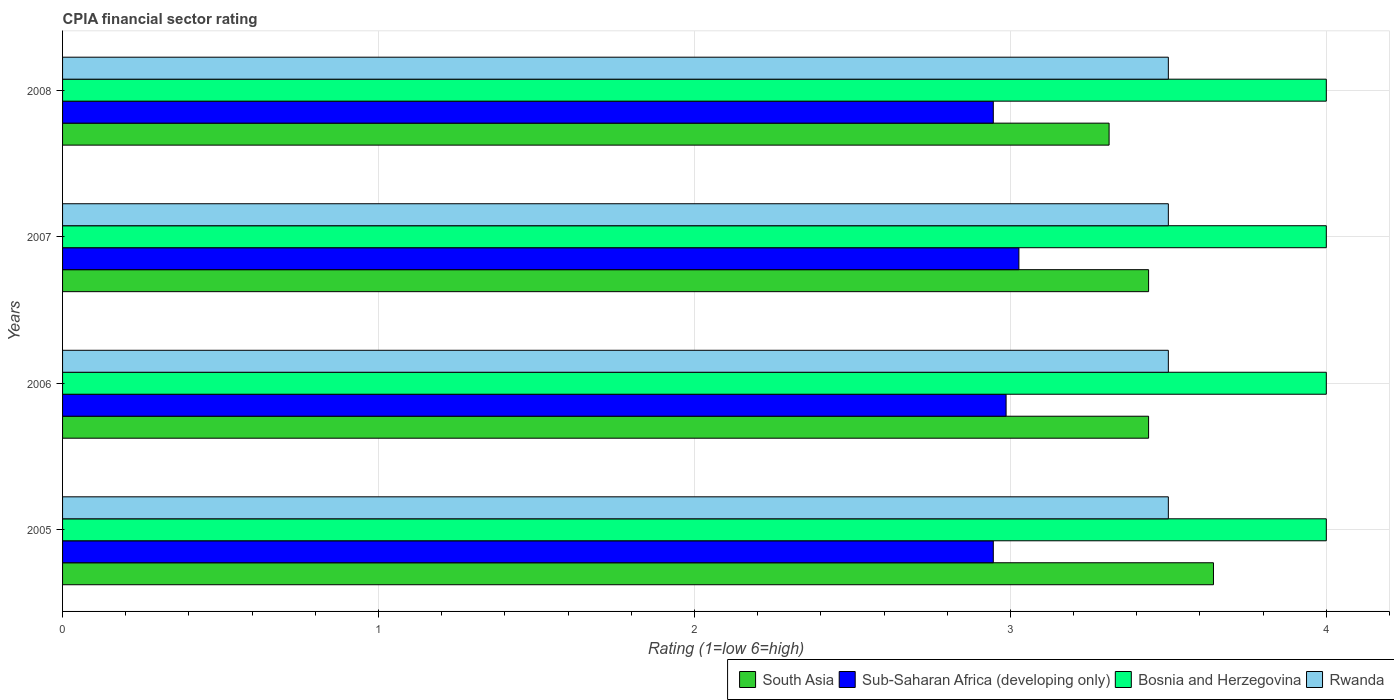How many different coloured bars are there?
Provide a short and direct response. 4. Are the number of bars on each tick of the Y-axis equal?
Give a very brief answer. Yes. How many bars are there on the 2nd tick from the top?
Provide a succinct answer. 4. What is the label of the 2nd group of bars from the top?
Your answer should be very brief. 2007. In how many cases, is the number of bars for a given year not equal to the number of legend labels?
Make the answer very short. 0. What is the CPIA rating in Sub-Saharan Africa (developing only) in 2007?
Make the answer very short. 3.03. Across all years, what is the maximum CPIA rating in South Asia?
Keep it short and to the point. 3.64. In which year was the CPIA rating in Rwanda maximum?
Offer a terse response. 2005. What is the difference between the CPIA rating in South Asia in 2005 and that in 2007?
Your answer should be very brief. 0.21. What is the difference between the CPIA rating in South Asia in 2006 and the CPIA rating in Sub-Saharan Africa (developing only) in 2007?
Offer a very short reply. 0.41. What is the average CPIA rating in Sub-Saharan Africa (developing only) per year?
Give a very brief answer. 2.98. In the year 2006, what is the difference between the CPIA rating in Sub-Saharan Africa (developing only) and CPIA rating in Bosnia and Herzegovina?
Give a very brief answer. -1.01. In how many years, is the CPIA rating in Rwanda greater than 1.6 ?
Offer a very short reply. 4. Is it the case that in every year, the sum of the CPIA rating in Sub-Saharan Africa (developing only) and CPIA rating in Rwanda is greater than the sum of CPIA rating in South Asia and CPIA rating in Bosnia and Herzegovina?
Offer a very short reply. No. What does the 1st bar from the top in 2007 represents?
Give a very brief answer. Rwanda. Is it the case that in every year, the sum of the CPIA rating in Rwanda and CPIA rating in Bosnia and Herzegovina is greater than the CPIA rating in Sub-Saharan Africa (developing only)?
Your response must be concise. Yes. What is the difference between two consecutive major ticks on the X-axis?
Your answer should be compact. 1. Does the graph contain any zero values?
Your response must be concise. No. How are the legend labels stacked?
Provide a succinct answer. Horizontal. What is the title of the graph?
Your response must be concise. CPIA financial sector rating. What is the label or title of the X-axis?
Your response must be concise. Rating (1=low 6=high). What is the label or title of the Y-axis?
Offer a terse response. Years. What is the Rating (1=low 6=high) of South Asia in 2005?
Offer a very short reply. 3.64. What is the Rating (1=low 6=high) of Sub-Saharan Africa (developing only) in 2005?
Provide a short and direct response. 2.95. What is the Rating (1=low 6=high) of Rwanda in 2005?
Offer a terse response. 3.5. What is the Rating (1=low 6=high) of South Asia in 2006?
Your answer should be very brief. 3.44. What is the Rating (1=low 6=high) of Sub-Saharan Africa (developing only) in 2006?
Your answer should be compact. 2.99. What is the Rating (1=low 6=high) in South Asia in 2007?
Your response must be concise. 3.44. What is the Rating (1=low 6=high) in Sub-Saharan Africa (developing only) in 2007?
Make the answer very short. 3.03. What is the Rating (1=low 6=high) in Rwanda in 2007?
Your response must be concise. 3.5. What is the Rating (1=low 6=high) in South Asia in 2008?
Provide a succinct answer. 3.31. What is the Rating (1=low 6=high) of Sub-Saharan Africa (developing only) in 2008?
Offer a very short reply. 2.95. Across all years, what is the maximum Rating (1=low 6=high) of South Asia?
Provide a succinct answer. 3.64. Across all years, what is the maximum Rating (1=low 6=high) in Sub-Saharan Africa (developing only)?
Your response must be concise. 3.03. Across all years, what is the maximum Rating (1=low 6=high) of Bosnia and Herzegovina?
Ensure brevity in your answer.  4. Across all years, what is the maximum Rating (1=low 6=high) of Rwanda?
Make the answer very short. 3.5. Across all years, what is the minimum Rating (1=low 6=high) in South Asia?
Your answer should be compact. 3.31. Across all years, what is the minimum Rating (1=low 6=high) in Sub-Saharan Africa (developing only)?
Give a very brief answer. 2.95. Across all years, what is the minimum Rating (1=low 6=high) of Bosnia and Herzegovina?
Ensure brevity in your answer.  4. Across all years, what is the minimum Rating (1=low 6=high) in Rwanda?
Your answer should be compact. 3.5. What is the total Rating (1=low 6=high) in South Asia in the graph?
Ensure brevity in your answer.  13.83. What is the total Rating (1=low 6=high) of Sub-Saharan Africa (developing only) in the graph?
Give a very brief answer. 11.91. What is the total Rating (1=low 6=high) in Bosnia and Herzegovina in the graph?
Your answer should be very brief. 16. What is the total Rating (1=low 6=high) of Rwanda in the graph?
Make the answer very short. 14. What is the difference between the Rating (1=low 6=high) of South Asia in 2005 and that in 2006?
Provide a succinct answer. 0.21. What is the difference between the Rating (1=low 6=high) in Sub-Saharan Africa (developing only) in 2005 and that in 2006?
Ensure brevity in your answer.  -0.04. What is the difference between the Rating (1=low 6=high) of South Asia in 2005 and that in 2007?
Provide a succinct answer. 0.21. What is the difference between the Rating (1=low 6=high) of Sub-Saharan Africa (developing only) in 2005 and that in 2007?
Make the answer very short. -0.08. What is the difference between the Rating (1=low 6=high) in Bosnia and Herzegovina in 2005 and that in 2007?
Provide a short and direct response. 0. What is the difference between the Rating (1=low 6=high) in South Asia in 2005 and that in 2008?
Ensure brevity in your answer.  0.33. What is the difference between the Rating (1=low 6=high) in Sub-Saharan Africa (developing only) in 2005 and that in 2008?
Your answer should be very brief. 0. What is the difference between the Rating (1=low 6=high) in Sub-Saharan Africa (developing only) in 2006 and that in 2007?
Your response must be concise. -0.04. What is the difference between the Rating (1=low 6=high) in Bosnia and Herzegovina in 2006 and that in 2007?
Keep it short and to the point. 0. What is the difference between the Rating (1=low 6=high) of Rwanda in 2006 and that in 2007?
Ensure brevity in your answer.  0. What is the difference between the Rating (1=low 6=high) in Sub-Saharan Africa (developing only) in 2006 and that in 2008?
Give a very brief answer. 0.04. What is the difference between the Rating (1=low 6=high) of Rwanda in 2006 and that in 2008?
Your response must be concise. 0. What is the difference between the Rating (1=low 6=high) in South Asia in 2007 and that in 2008?
Provide a succinct answer. 0.12. What is the difference between the Rating (1=low 6=high) of Sub-Saharan Africa (developing only) in 2007 and that in 2008?
Provide a succinct answer. 0.08. What is the difference between the Rating (1=low 6=high) in Rwanda in 2007 and that in 2008?
Your response must be concise. 0. What is the difference between the Rating (1=low 6=high) of South Asia in 2005 and the Rating (1=low 6=high) of Sub-Saharan Africa (developing only) in 2006?
Your answer should be very brief. 0.66. What is the difference between the Rating (1=low 6=high) in South Asia in 2005 and the Rating (1=low 6=high) in Bosnia and Herzegovina in 2006?
Your answer should be compact. -0.36. What is the difference between the Rating (1=low 6=high) of South Asia in 2005 and the Rating (1=low 6=high) of Rwanda in 2006?
Ensure brevity in your answer.  0.14. What is the difference between the Rating (1=low 6=high) in Sub-Saharan Africa (developing only) in 2005 and the Rating (1=low 6=high) in Bosnia and Herzegovina in 2006?
Your answer should be very brief. -1.05. What is the difference between the Rating (1=low 6=high) of Sub-Saharan Africa (developing only) in 2005 and the Rating (1=low 6=high) of Rwanda in 2006?
Provide a succinct answer. -0.55. What is the difference between the Rating (1=low 6=high) in Bosnia and Herzegovina in 2005 and the Rating (1=low 6=high) in Rwanda in 2006?
Your answer should be compact. 0.5. What is the difference between the Rating (1=low 6=high) in South Asia in 2005 and the Rating (1=low 6=high) in Sub-Saharan Africa (developing only) in 2007?
Give a very brief answer. 0.62. What is the difference between the Rating (1=low 6=high) in South Asia in 2005 and the Rating (1=low 6=high) in Bosnia and Herzegovina in 2007?
Provide a succinct answer. -0.36. What is the difference between the Rating (1=low 6=high) in South Asia in 2005 and the Rating (1=low 6=high) in Rwanda in 2007?
Offer a terse response. 0.14. What is the difference between the Rating (1=low 6=high) of Sub-Saharan Africa (developing only) in 2005 and the Rating (1=low 6=high) of Bosnia and Herzegovina in 2007?
Your answer should be compact. -1.05. What is the difference between the Rating (1=low 6=high) in Sub-Saharan Africa (developing only) in 2005 and the Rating (1=low 6=high) in Rwanda in 2007?
Offer a very short reply. -0.55. What is the difference between the Rating (1=low 6=high) of Bosnia and Herzegovina in 2005 and the Rating (1=low 6=high) of Rwanda in 2007?
Your answer should be compact. 0.5. What is the difference between the Rating (1=low 6=high) of South Asia in 2005 and the Rating (1=low 6=high) of Sub-Saharan Africa (developing only) in 2008?
Offer a terse response. 0.7. What is the difference between the Rating (1=low 6=high) of South Asia in 2005 and the Rating (1=low 6=high) of Bosnia and Herzegovina in 2008?
Offer a very short reply. -0.36. What is the difference between the Rating (1=low 6=high) in South Asia in 2005 and the Rating (1=low 6=high) in Rwanda in 2008?
Make the answer very short. 0.14. What is the difference between the Rating (1=low 6=high) of Sub-Saharan Africa (developing only) in 2005 and the Rating (1=low 6=high) of Bosnia and Herzegovina in 2008?
Keep it short and to the point. -1.05. What is the difference between the Rating (1=low 6=high) in Sub-Saharan Africa (developing only) in 2005 and the Rating (1=low 6=high) in Rwanda in 2008?
Your answer should be compact. -0.55. What is the difference between the Rating (1=low 6=high) of Bosnia and Herzegovina in 2005 and the Rating (1=low 6=high) of Rwanda in 2008?
Ensure brevity in your answer.  0.5. What is the difference between the Rating (1=low 6=high) of South Asia in 2006 and the Rating (1=low 6=high) of Sub-Saharan Africa (developing only) in 2007?
Keep it short and to the point. 0.41. What is the difference between the Rating (1=low 6=high) in South Asia in 2006 and the Rating (1=low 6=high) in Bosnia and Herzegovina in 2007?
Offer a very short reply. -0.56. What is the difference between the Rating (1=low 6=high) in South Asia in 2006 and the Rating (1=low 6=high) in Rwanda in 2007?
Ensure brevity in your answer.  -0.06. What is the difference between the Rating (1=low 6=high) in Sub-Saharan Africa (developing only) in 2006 and the Rating (1=low 6=high) in Bosnia and Herzegovina in 2007?
Provide a short and direct response. -1.01. What is the difference between the Rating (1=low 6=high) in Sub-Saharan Africa (developing only) in 2006 and the Rating (1=low 6=high) in Rwanda in 2007?
Your answer should be very brief. -0.51. What is the difference between the Rating (1=low 6=high) of Bosnia and Herzegovina in 2006 and the Rating (1=low 6=high) of Rwanda in 2007?
Your response must be concise. 0.5. What is the difference between the Rating (1=low 6=high) in South Asia in 2006 and the Rating (1=low 6=high) in Sub-Saharan Africa (developing only) in 2008?
Give a very brief answer. 0.49. What is the difference between the Rating (1=low 6=high) of South Asia in 2006 and the Rating (1=low 6=high) of Bosnia and Herzegovina in 2008?
Offer a very short reply. -0.56. What is the difference between the Rating (1=low 6=high) of South Asia in 2006 and the Rating (1=low 6=high) of Rwanda in 2008?
Provide a succinct answer. -0.06. What is the difference between the Rating (1=low 6=high) of Sub-Saharan Africa (developing only) in 2006 and the Rating (1=low 6=high) of Bosnia and Herzegovina in 2008?
Give a very brief answer. -1.01. What is the difference between the Rating (1=low 6=high) of Sub-Saharan Africa (developing only) in 2006 and the Rating (1=low 6=high) of Rwanda in 2008?
Make the answer very short. -0.51. What is the difference between the Rating (1=low 6=high) in South Asia in 2007 and the Rating (1=low 6=high) in Sub-Saharan Africa (developing only) in 2008?
Ensure brevity in your answer.  0.49. What is the difference between the Rating (1=low 6=high) in South Asia in 2007 and the Rating (1=low 6=high) in Bosnia and Herzegovina in 2008?
Provide a short and direct response. -0.56. What is the difference between the Rating (1=low 6=high) in South Asia in 2007 and the Rating (1=low 6=high) in Rwanda in 2008?
Make the answer very short. -0.06. What is the difference between the Rating (1=low 6=high) of Sub-Saharan Africa (developing only) in 2007 and the Rating (1=low 6=high) of Bosnia and Herzegovina in 2008?
Provide a succinct answer. -0.97. What is the difference between the Rating (1=low 6=high) of Sub-Saharan Africa (developing only) in 2007 and the Rating (1=low 6=high) of Rwanda in 2008?
Provide a succinct answer. -0.47. What is the difference between the Rating (1=low 6=high) in Bosnia and Herzegovina in 2007 and the Rating (1=low 6=high) in Rwanda in 2008?
Make the answer very short. 0.5. What is the average Rating (1=low 6=high) in South Asia per year?
Your response must be concise. 3.46. What is the average Rating (1=low 6=high) in Sub-Saharan Africa (developing only) per year?
Your answer should be compact. 2.98. In the year 2005, what is the difference between the Rating (1=low 6=high) of South Asia and Rating (1=low 6=high) of Sub-Saharan Africa (developing only)?
Give a very brief answer. 0.7. In the year 2005, what is the difference between the Rating (1=low 6=high) in South Asia and Rating (1=low 6=high) in Bosnia and Herzegovina?
Your answer should be very brief. -0.36. In the year 2005, what is the difference between the Rating (1=low 6=high) of South Asia and Rating (1=low 6=high) of Rwanda?
Provide a short and direct response. 0.14. In the year 2005, what is the difference between the Rating (1=low 6=high) of Sub-Saharan Africa (developing only) and Rating (1=low 6=high) of Bosnia and Herzegovina?
Make the answer very short. -1.05. In the year 2005, what is the difference between the Rating (1=low 6=high) of Sub-Saharan Africa (developing only) and Rating (1=low 6=high) of Rwanda?
Ensure brevity in your answer.  -0.55. In the year 2006, what is the difference between the Rating (1=low 6=high) in South Asia and Rating (1=low 6=high) in Sub-Saharan Africa (developing only)?
Ensure brevity in your answer.  0.45. In the year 2006, what is the difference between the Rating (1=low 6=high) in South Asia and Rating (1=low 6=high) in Bosnia and Herzegovina?
Your answer should be compact. -0.56. In the year 2006, what is the difference between the Rating (1=low 6=high) in South Asia and Rating (1=low 6=high) in Rwanda?
Keep it short and to the point. -0.06. In the year 2006, what is the difference between the Rating (1=low 6=high) of Sub-Saharan Africa (developing only) and Rating (1=low 6=high) of Bosnia and Herzegovina?
Keep it short and to the point. -1.01. In the year 2006, what is the difference between the Rating (1=low 6=high) of Sub-Saharan Africa (developing only) and Rating (1=low 6=high) of Rwanda?
Make the answer very short. -0.51. In the year 2006, what is the difference between the Rating (1=low 6=high) of Bosnia and Herzegovina and Rating (1=low 6=high) of Rwanda?
Offer a very short reply. 0.5. In the year 2007, what is the difference between the Rating (1=low 6=high) of South Asia and Rating (1=low 6=high) of Sub-Saharan Africa (developing only)?
Your answer should be compact. 0.41. In the year 2007, what is the difference between the Rating (1=low 6=high) of South Asia and Rating (1=low 6=high) of Bosnia and Herzegovina?
Offer a terse response. -0.56. In the year 2007, what is the difference between the Rating (1=low 6=high) of South Asia and Rating (1=low 6=high) of Rwanda?
Offer a terse response. -0.06. In the year 2007, what is the difference between the Rating (1=low 6=high) of Sub-Saharan Africa (developing only) and Rating (1=low 6=high) of Bosnia and Herzegovina?
Ensure brevity in your answer.  -0.97. In the year 2007, what is the difference between the Rating (1=low 6=high) in Sub-Saharan Africa (developing only) and Rating (1=low 6=high) in Rwanda?
Provide a succinct answer. -0.47. In the year 2007, what is the difference between the Rating (1=low 6=high) of Bosnia and Herzegovina and Rating (1=low 6=high) of Rwanda?
Keep it short and to the point. 0.5. In the year 2008, what is the difference between the Rating (1=low 6=high) of South Asia and Rating (1=low 6=high) of Sub-Saharan Africa (developing only)?
Offer a very short reply. 0.37. In the year 2008, what is the difference between the Rating (1=low 6=high) in South Asia and Rating (1=low 6=high) in Bosnia and Herzegovina?
Your answer should be compact. -0.69. In the year 2008, what is the difference between the Rating (1=low 6=high) of South Asia and Rating (1=low 6=high) of Rwanda?
Your answer should be compact. -0.19. In the year 2008, what is the difference between the Rating (1=low 6=high) of Sub-Saharan Africa (developing only) and Rating (1=low 6=high) of Bosnia and Herzegovina?
Provide a succinct answer. -1.05. In the year 2008, what is the difference between the Rating (1=low 6=high) of Sub-Saharan Africa (developing only) and Rating (1=low 6=high) of Rwanda?
Make the answer very short. -0.55. What is the ratio of the Rating (1=low 6=high) of South Asia in 2005 to that in 2006?
Make the answer very short. 1.06. What is the ratio of the Rating (1=low 6=high) of Sub-Saharan Africa (developing only) in 2005 to that in 2006?
Offer a very short reply. 0.99. What is the ratio of the Rating (1=low 6=high) in Bosnia and Herzegovina in 2005 to that in 2006?
Provide a succinct answer. 1. What is the ratio of the Rating (1=low 6=high) in South Asia in 2005 to that in 2007?
Keep it short and to the point. 1.06. What is the ratio of the Rating (1=low 6=high) in Sub-Saharan Africa (developing only) in 2005 to that in 2007?
Offer a very short reply. 0.97. What is the ratio of the Rating (1=low 6=high) of South Asia in 2005 to that in 2008?
Your answer should be compact. 1.1. What is the ratio of the Rating (1=low 6=high) in South Asia in 2006 to that in 2007?
Keep it short and to the point. 1. What is the ratio of the Rating (1=low 6=high) in Sub-Saharan Africa (developing only) in 2006 to that in 2007?
Provide a short and direct response. 0.99. What is the ratio of the Rating (1=low 6=high) in Bosnia and Herzegovina in 2006 to that in 2007?
Provide a succinct answer. 1. What is the ratio of the Rating (1=low 6=high) in South Asia in 2006 to that in 2008?
Your answer should be very brief. 1.04. What is the ratio of the Rating (1=low 6=high) of Sub-Saharan Africa (developing only) in 2006 to that in 2008?
Provide a short and direct response. 1.01. What is the ratio of the Rating (1=low 6=high) of Bosnia and Herzegovina in 2006 to that in 2008?
Your answer should be very brief. 1. What is the ratio of the Rating (1=low 6=high) of South Asia in 2007 to that in 2008?
Your answer should be compact. 1.04. What is the ratio of the Rating (1=low 6=high) of Sub-Saharan Africa (developing only) in 2007 to that in 2008?
Make the answer very short. 1.03. What is the difference between the highest and the second highest Rating (1=low 6=high) in South Asia?
Provide a succinct answer. 0.21. What is the difference between the highest and the second highest Rating (1=low 6=high) of Sub-Saharan Africa (developing only)?
Offer a terse response. 0.04. What is the difference between the highest and the second highest Rating (1=low 6=high) in Bosnia and Herzegovina?
Provide a succinct answer. 0. What is the difference between the highest and the lowest Rating (1=low 6=high) in South Asia?
Make the answer very short. 0.33. What is the difference between the highest and the lowest Rating (1=low 6=high) of Sub-Saharan Africa (developing only)?
Provide a succinct answer. 0.08. What is the difference between the highest and the lowest Rating (1=low 6=high) of Bosnia and Herzegovina?
Offer a terse response. 0. 